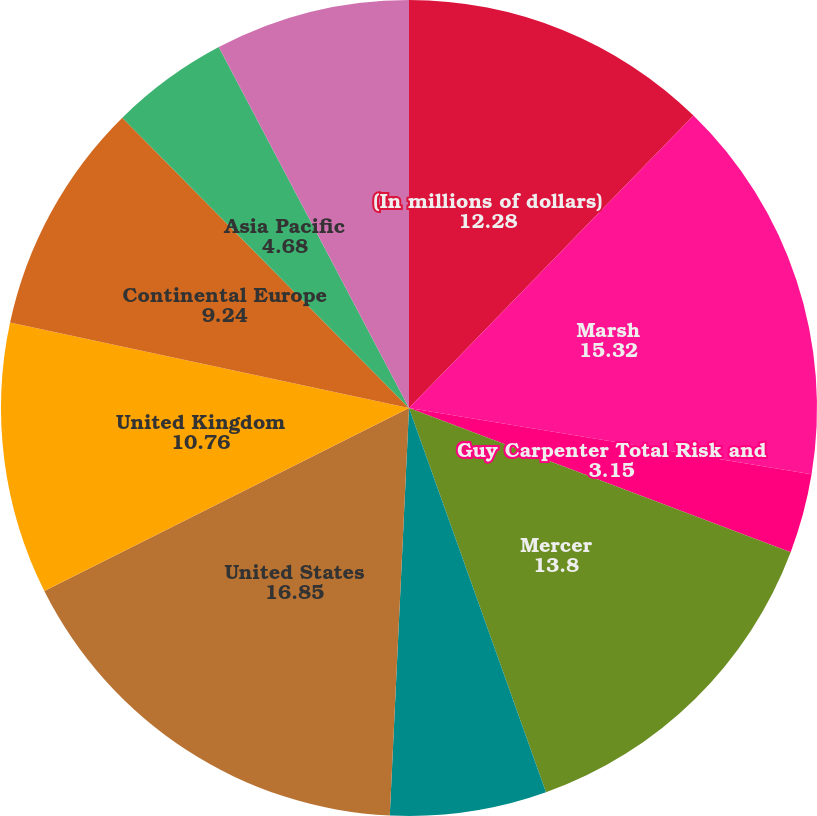Convert chart to OTSL. <chart><loc_0><loc_0><loc_500><loc_500><pie_chart><fcel>(In millions of dollars)<fcel>Marsh<fcel>Guy Carpenter Total Risk and<fcel>Mercer<fcel>Oliver Wyman Group Total<fcel>United States<fcel>United Kingdom<fcel>Continental Europe<fcel>Asia Pacific<fcel>Other<nl><fcel>12.28%<fcel>15.32%<fcel>3.15%<fcel>13.8%<fcel>6.2%<fcel>16.85%<fcel>10.76%<fcel>9.24%<fcel>4.68%<fcel>7.72%<nl></chart> 